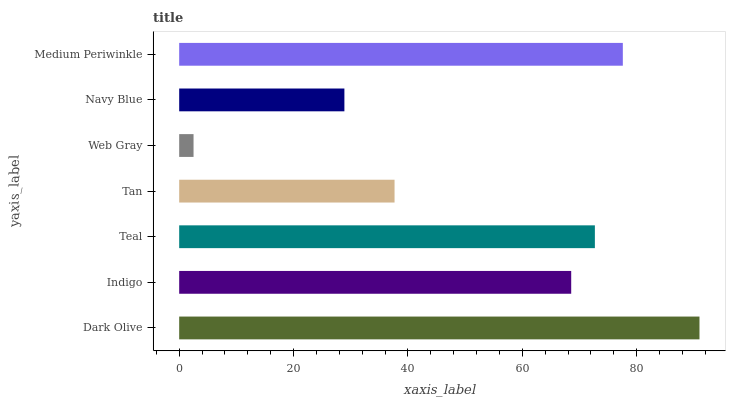Is Web Gray the minimum?
Answer yes or no. Yes. Is Dark Olive the maximum?
Answer yes or no. Yes. Is Indigo the minimum?
Answer yes or no. No. Is Indigo the maximum?
Answer yes or no. No. Is Dark Olive greater than Indigo?
Answer yes or no. Yes. Is Indigo less than Dark Olive?
Answer yes or no. Yes. Is Indigo greater than Dark Olive?
Answer yes or no. No. Is Dark Olive less than Indigo?
Answer yes or no. No. Is Indigo the high median?
Answer yes or no. Yes. Is Indigo the low median?
Answer yes or no. Yes. Is Dark Olive the high median?
Answer yes or no. No. Is Medium Periwinkle the low median?
Answer yes or no. No. 